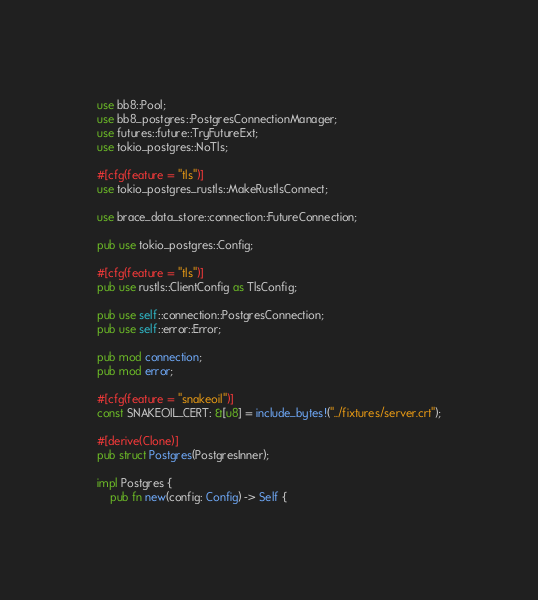Convert code to text. <code><loc_0><loc_0><loc_500><loc_500><_Rust_>use bb8::Pool;
use bb8_postgres::PostgresConnectionManager;
use futures::future::TryFutureExt;
use tokio_postgres::NoTls;

#[cfg(feature = "tls")]
use tokio_postgres_rustls::MakeRustlsConnect;

use brace_data_store::connection::FutureConnection;

pub use tokio_postgres::Config;

#[cfg(feature = "tls")]
pub use rustls::ClientConfig as TlsConfig;

pub use self::connection::PostgresConnection;
pub use self::error::Error;

pub mod connection;
pub mod error;

#[cfg(feature = "snakeoil")]
const SNAKEOIL_CERT: &[u8] = include_bytes!("../fixtures/server.crt");

#[derive(Clone)]
pub struct Postgres(PostgresInner);

impl Postgres {
    pub fn new(config: Config) -> Self {</code> 